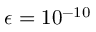<formula> <loc_0><loc_0><loc_500><loc_500>\epsilon = 1 0 ^ { - 1 0 }</formula> 